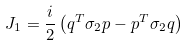<formula> <loc_0><loc_0><loc_500><loc_500>J _ { 1 } = { \frac { i } { 2 } } \left ( q ^ { T } \sigma _ { 2 } p - p ^ { T } \sigma _ { 2 } q \right )</formula> 